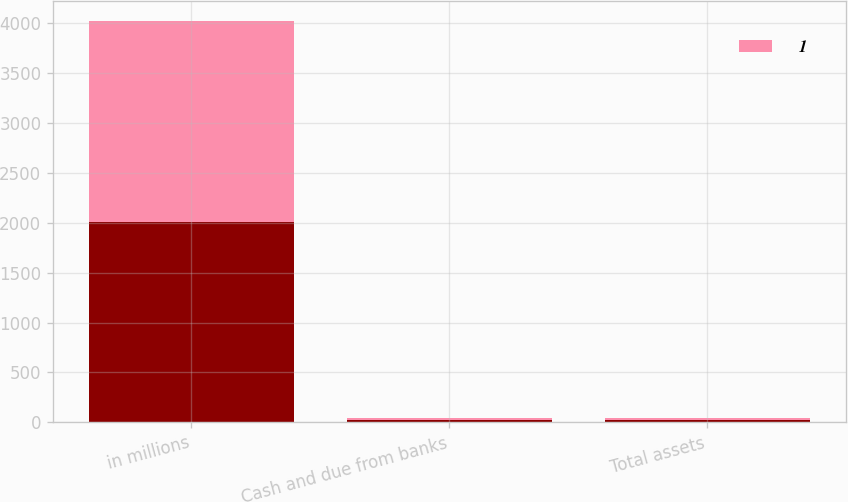Convert chart to OTSL. <chart><loc_0><loc_0><loc_500><loc_500><stacked_bar_chart><ecel><fcel>in millions<fcel>Cash and due from banks<fcel>Total assets<nl><fcel>nan<fcel>2013<fcel>20<fcel>20<nl><fcel>1<fcel>2012<fcel>22<fcel>22<nl></chart> 